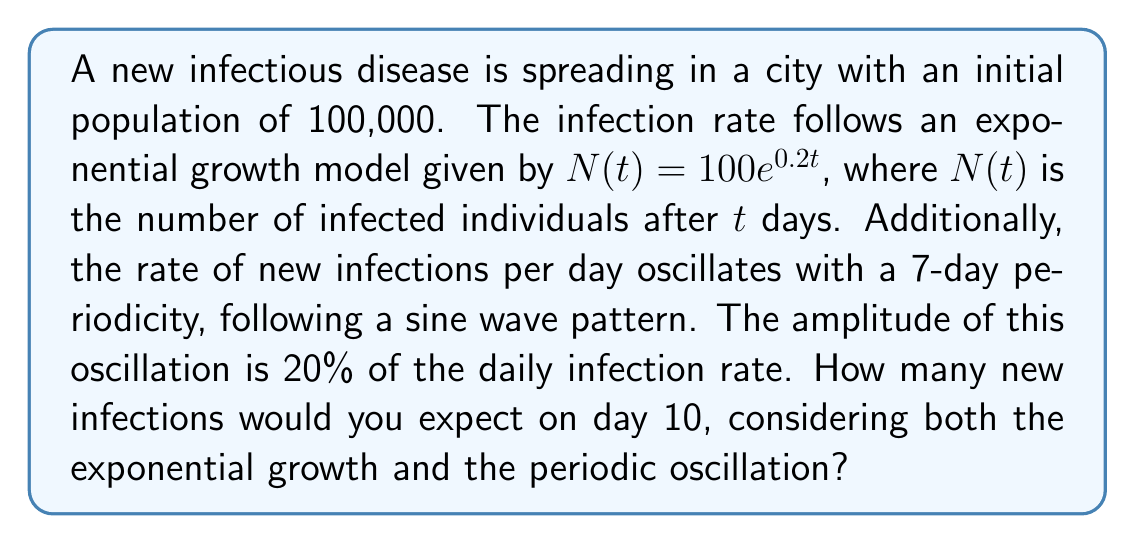Show me your answer to this math problem. Let's approach this step-by-step:

1) First, we need to find the number of infections on day 10 using the exponential growth model:
   $N(10) = 100e^{0.2 \cdot 10} = 100e^2 \approx 738.91$

2) To find the number of new infections on day 10, we need to calculate the derivative of $N(t)$ at $t=10$:
   $N'(t) = 20e^{0.2t}$
   $N'(10) = 20e^2 \approx 147.78$

3) This tells us that without oscillation, we'd expect about 147.78 new infections on day 10.

4) Now, we need to consider the oscillation. The sine wave has a period of 7 days, so its angular frequency $\omega$ is:
   $\omega = \frac{2\pi}{7}$

5) The oscillation is 20% of the daily infection rate, so its amplitude is:
   $0.2 \cdot 147.78 \approx 29.56$

6) The oscillation can be described by:
   $29.56 \sin(\frac{2\pi}{7}t)$

7) On day 10, the value of this oscillation is:
   $29.56 \sin(\frac{2\pi}{7} \cdot 10) \approx 22.59$

8) Therefore, the total number of new infections on day 10 is:
   $147.78 + 22.59 \approx 170.37$
Answer: $170$ new infections (rounded to nearest whole number) 